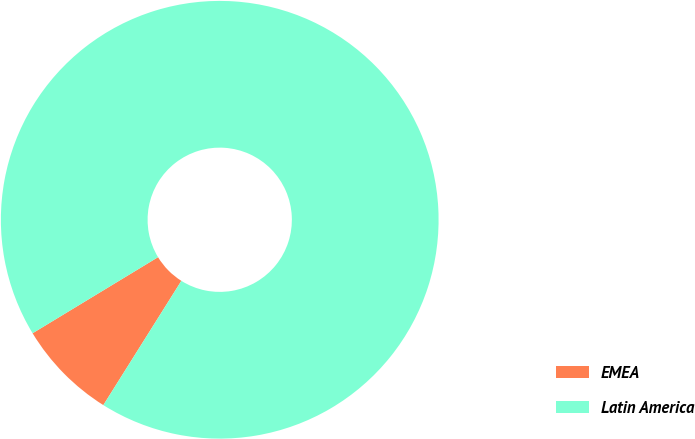<chart> <loc_0><loc_0><loc_500><loc_500><pie_chart><fcel>EMEA<fcel>Latin America<nl><fcel>7.4%<fcel>92.6%<nl></chart> 